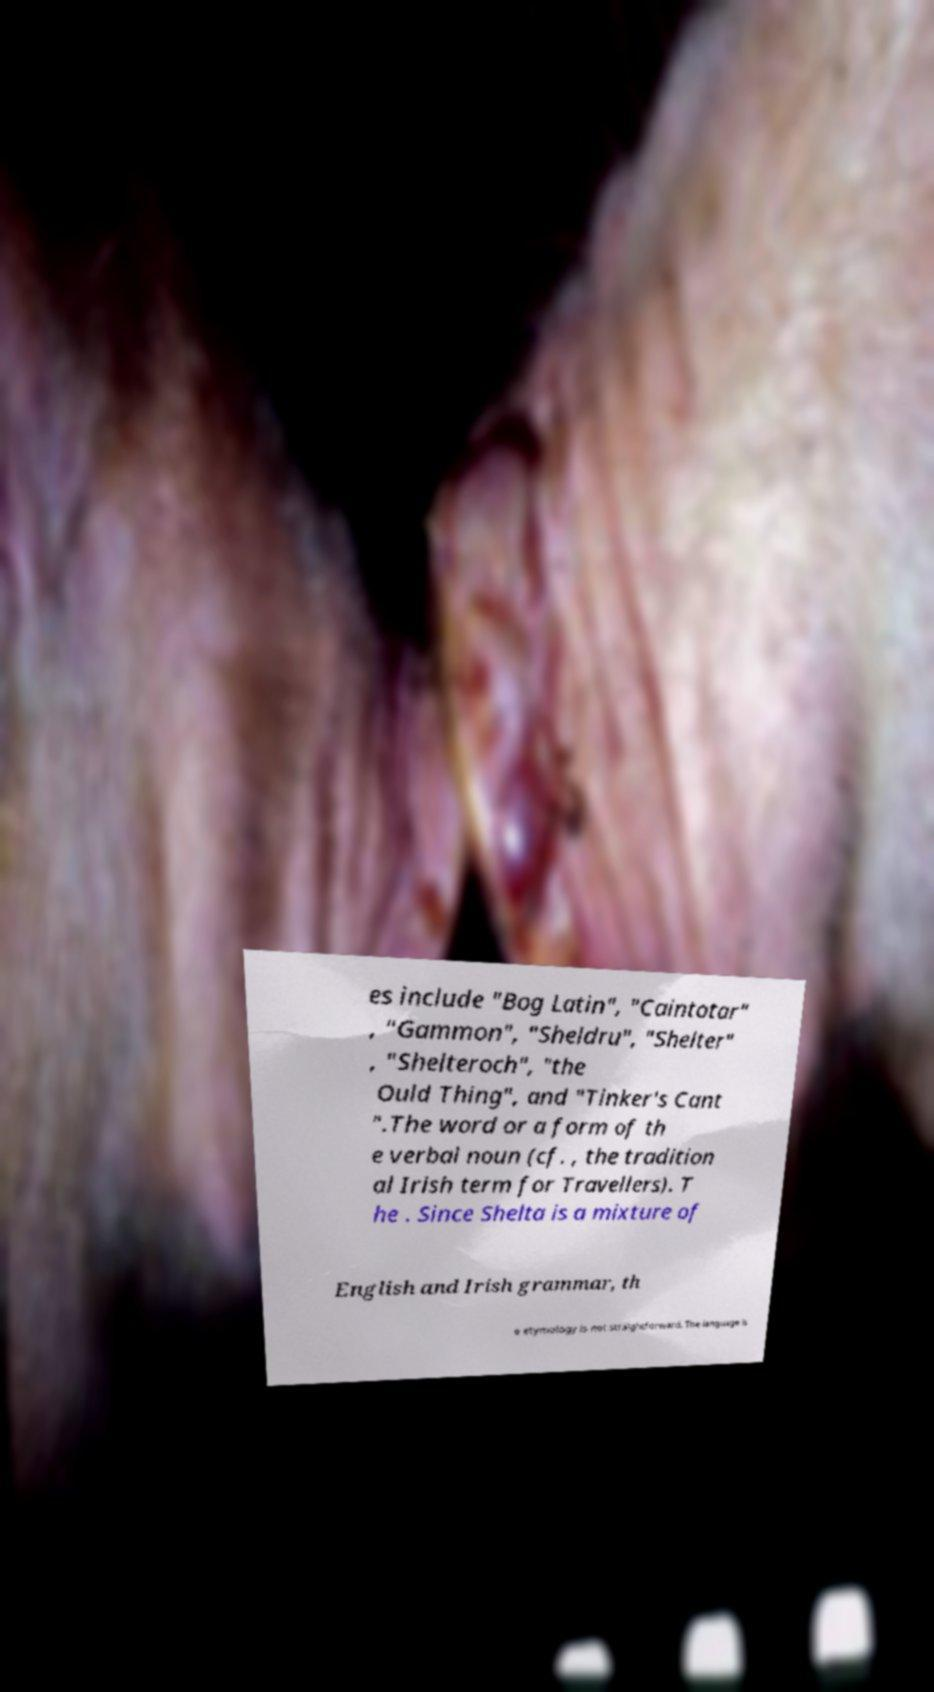I need the written content from this picture converted into text. Can you do that? es include "Bog Latin", "Caintotar" , "Gammon", "Sheldru", "Shelter" , "Shelteroch", "the Ould Thing", and "Tinker's Cant ".The word or a form of th e verbal noun (cf. , the tradition al Irish term for Travellers). T he . Since Shelta is a mixture of English and Irish grammar, th e etymology is not straightforward. The language is 